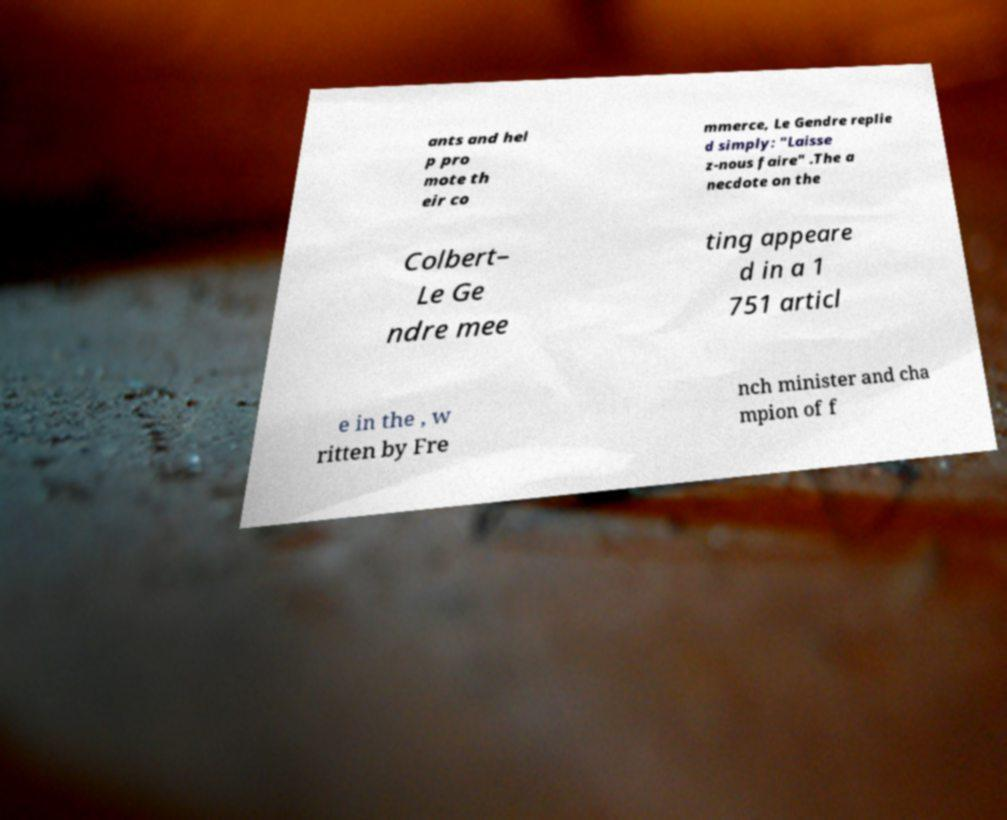What messages or text are displayed in this image? I need them in a readable, typed format. ants and hel p pro mote th eir co mmerce, Le Gendre replie d simply: "Laisse z-nous faire" .The a necdote on the Colbert– Le Ge ndre mee ting appeare d in a 1 751 articl e in the , w ritten by Fre nch minister and cha mpion of f 